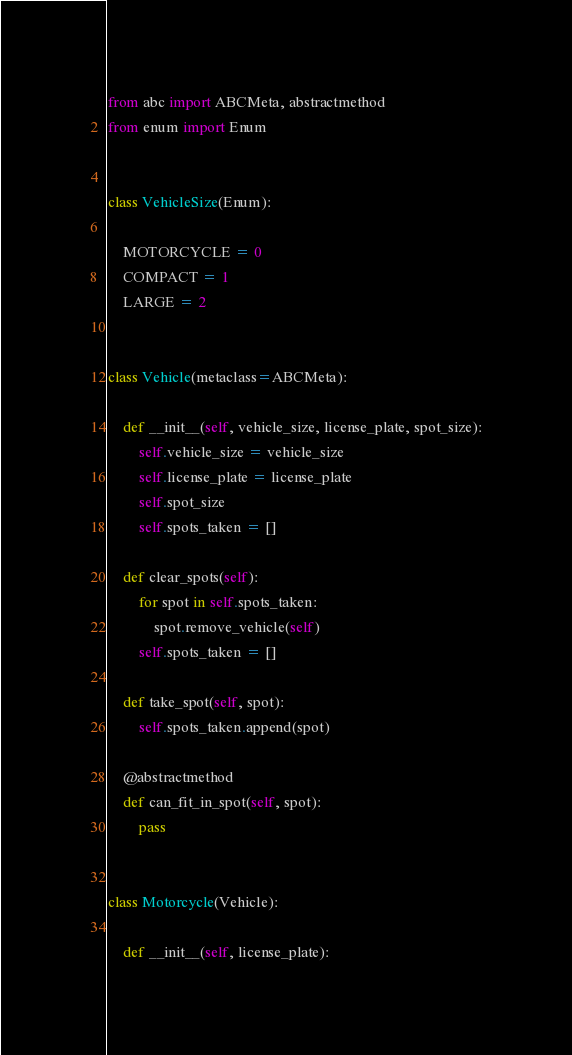<code> <loc_0><loc_0><loc_500><loc_500><_Python_>from abc import ABCMeta, abstractmethod
from enum import Enum


class VehicleSize(Enum):

    MOTORCYCLE = 0
    COMPACT = 1
    LARGE = 2


class Vehicle(metaclass=ABCMeta):

    def __init__(self, vehicle_size, license_plate, spot_size):
        self.vehicle_size = vehicle_size
        self.license_plate = license_plate
        self.spot_size
        self.spots_taken = []

    def clear_spots(self):
        for spot in self.spots_taken:
            spot.remove_vehicle(self)
        self.spots_taken = []

    def take_spot(self, spot):
        self.spots_taken.append(spot)

    @abstractmethod
    def can_fit_in_spot(self, spot):
        pass


class Motorcycle(Vehicle):

    def __init__(self, license_plate):</code> 